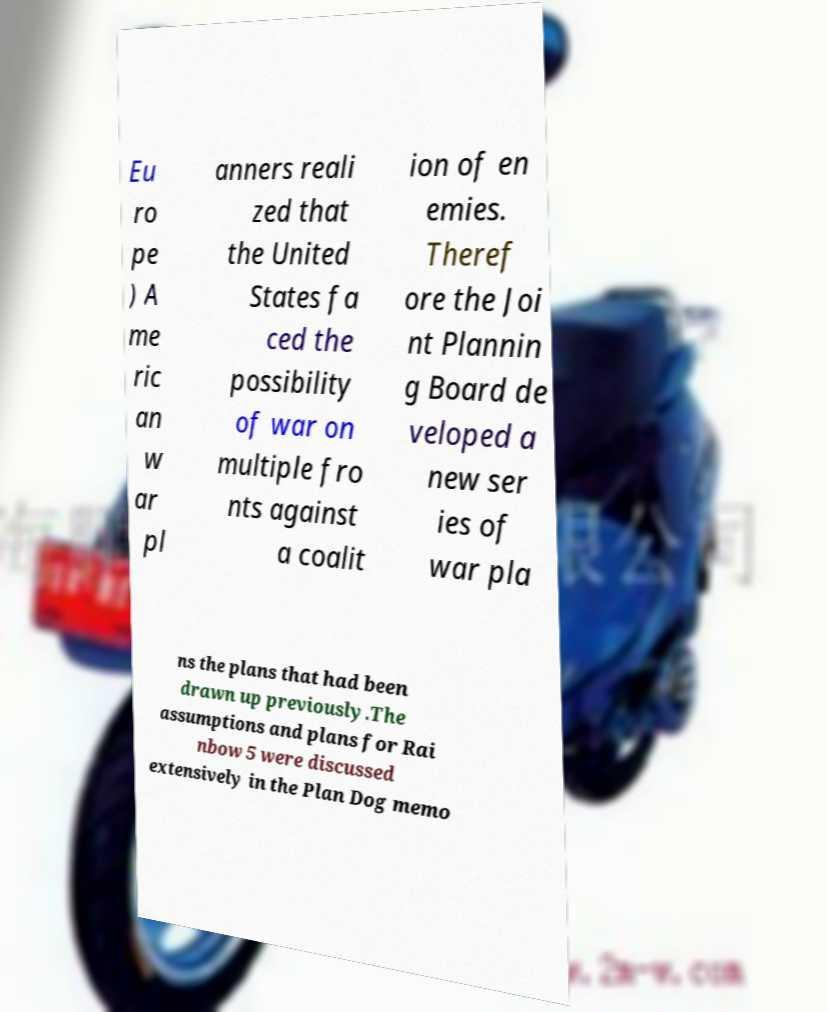Please identify and transcribe the text found in this image. Eu ro pe ) A me ric an w ar pl anners reali zed that the United States fa ced the possibility of war on multiple fro nts against a coalit ion of en emies. Theref ore the Joi nt Plannin g Board de veloped a new ser ies of war pla ns the plans that had been drawn up previously.The assumptions and plans for Rai nbow 5 were discussed extensively in the Plan Dog memo 